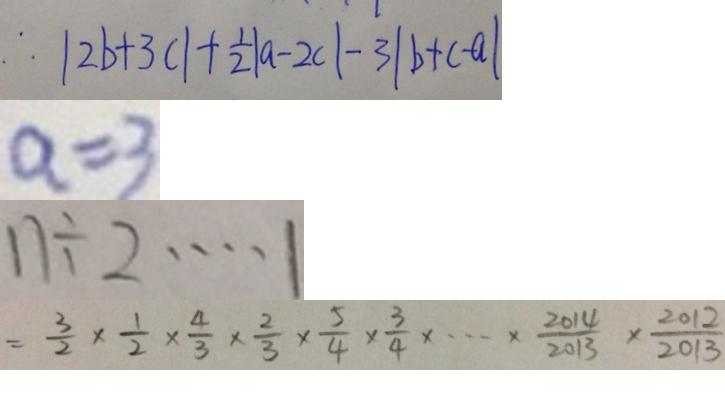Convert formula to latex. <formula><loc_0><loc_0><loc_500><loc_500>\therefore \vert 2 b + 3 c \vert + \frac { 1 } { 2 } \vert a - 2 c \vert - 3 \vert b + c - a \vert 
 a = 3 
 n \div 2 \cdots 1 
 = \frac { 3 } { 2 } \times \frac { 1 } { 2 } \times \frac { 4 } { 3 } \times \frac { 2 } { 3 } \times \frac { 5 } { 4 } \times \frac { 3 } { 4 } \times \cdots \times \frac { 2 0 1 4 } { 2 0 1 3 } \times \frac { 2 0 1 2 } { 2 0 1 3 }</formula> 